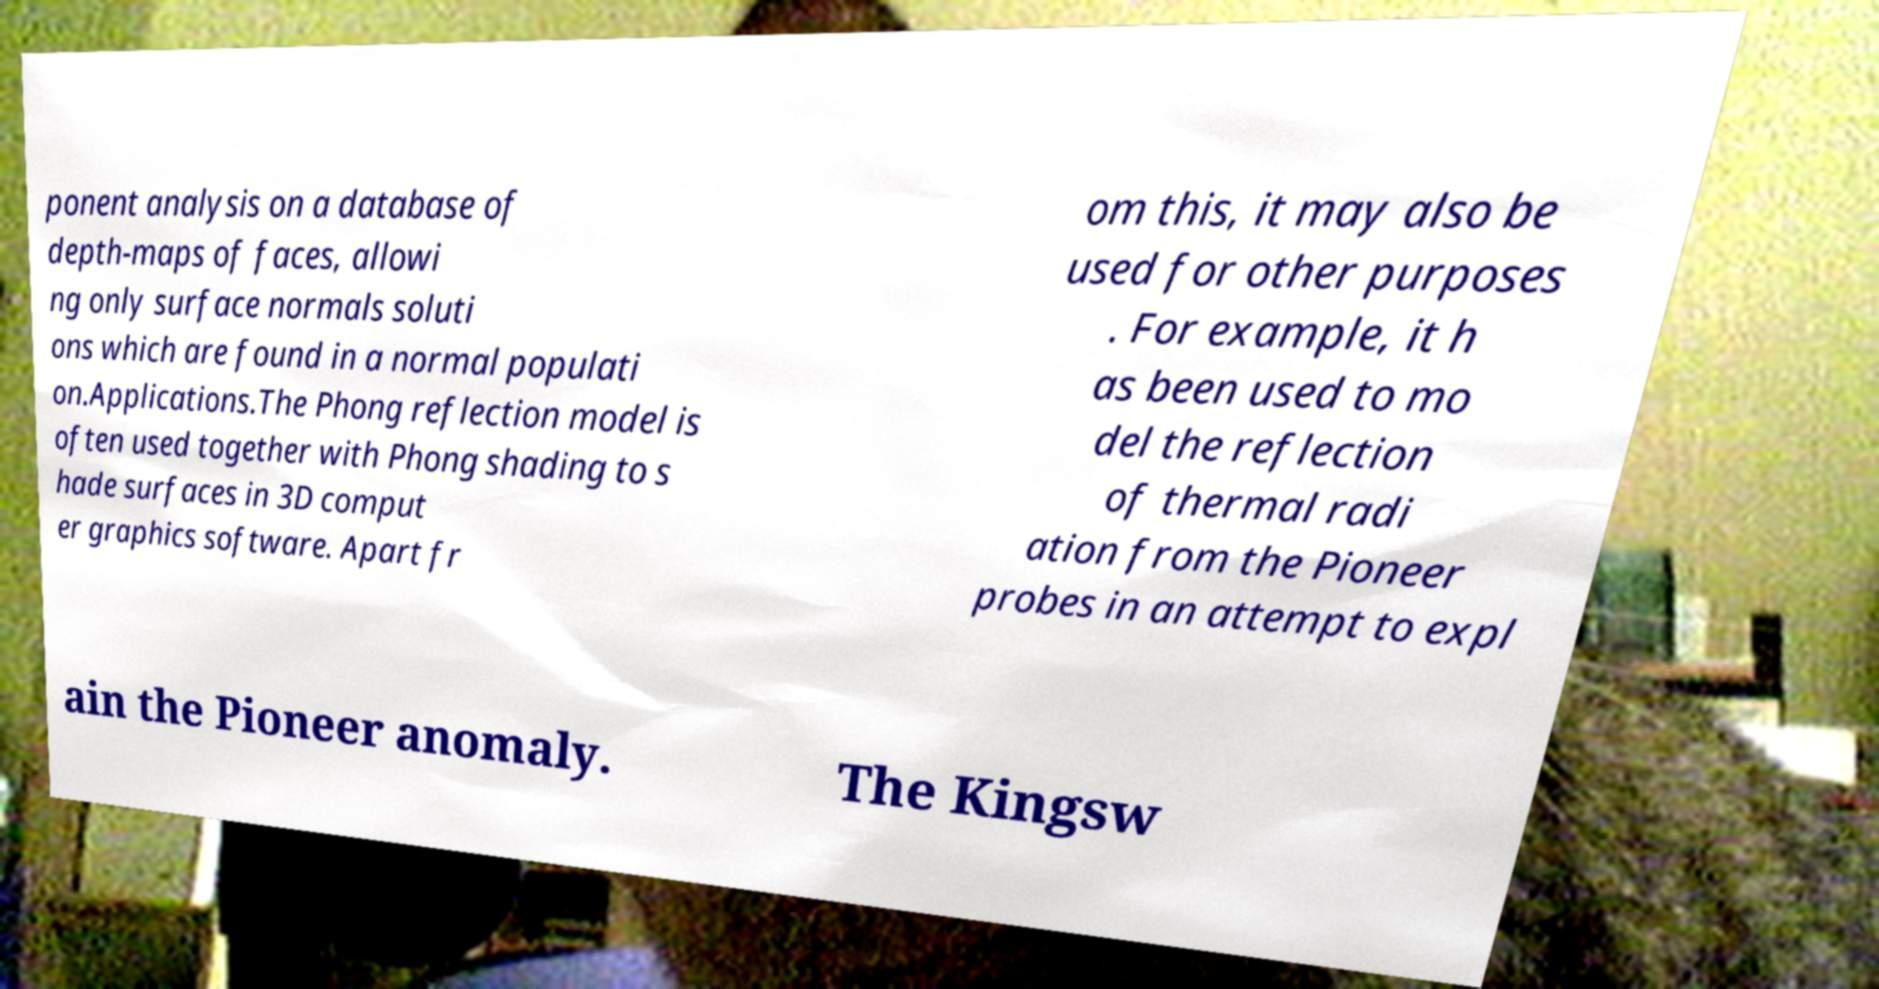For documentation purposes, I need the text within this image transcribed. Could you provide that? ponent analysis on a database of depth-maps of faces, allowi ng only surface normals soluti ons which are found in a normal populati on.Applications.The Phong reflection model is often used together with Phong shading to s hade surfaces in 3D comput er graphics software. Apart fr om this, it may also be used for other purposes . For example, it h as been used to mo del the reflection of thermal radi ation from the Pioneer probes in an attempt to expl ain the Pioneer anomaly. The Kingsw 